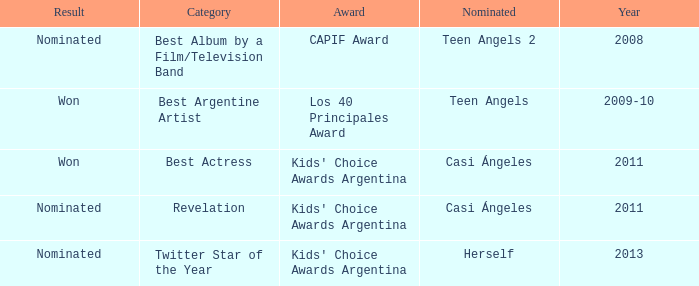What year was there a nomination for Best Actress at the Kids' Choice Awards Argentina? 2011.0. 